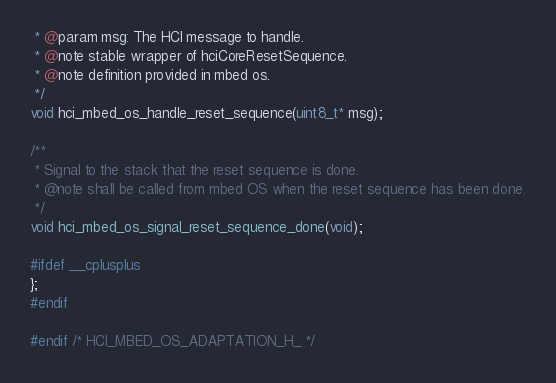Convert code to text. <code><loc_0><loc_0><loc_500><loc_500><_C_> * @param msg: The HCI message to handle.
 * @note stable wrapper of hciCoreResetSequence.
 * @note definition provided in mbed os.
 */
void hci_mbed_os_handle_reset_sequence(uint8_t* msg);

/**
 * Signal to the stack that the reset sequence is done.
 * @note shall be called from mbed OS when the reset sequence has been done.
 */
void hci_mbed_os_signal_reset_sequence_done(void);

#ifdef __cplusplus
};
#endif

#endif /* HCI_MBED_OS_ADAPTATION_H_ */
</code> 